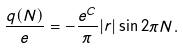Convert formula to latex. <formula><loc_0><loc_0><loc_500><loc_500>\frac { q ( N ) } { e } = - \frac { e ^ { C } } { \pi } | r | \sin 2 \pi N .</formula> 